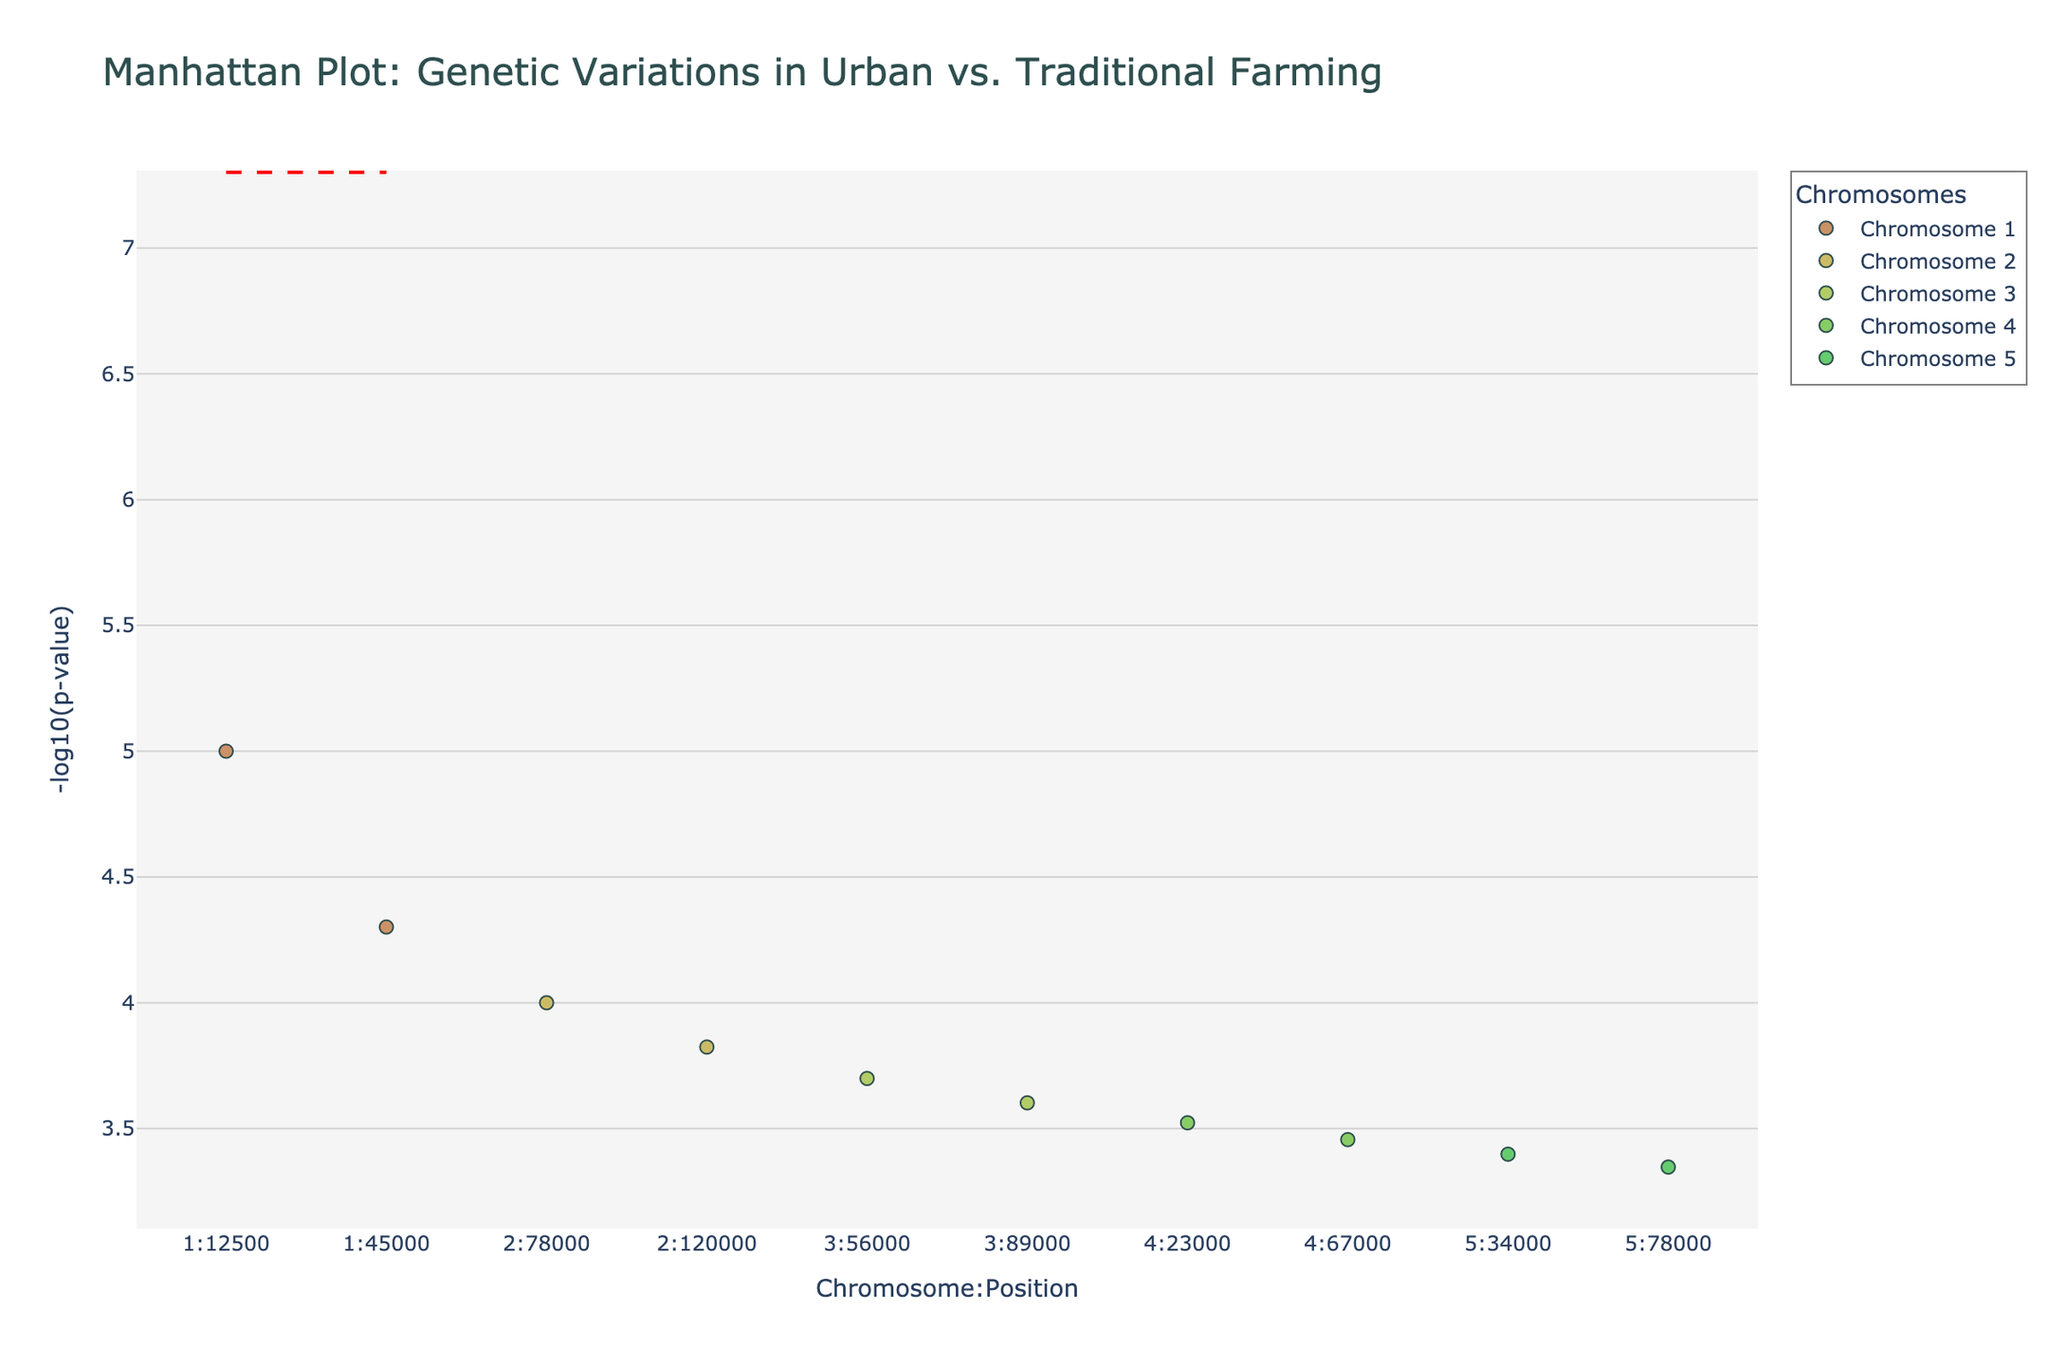What is the title of the plot? The title of the plot is displayed prominently at the top, and it reads "Manhattan Plot: Genetic Variations in Urban vs. Traditional Farming".
Answer: Manhattan Plot: Genetic Variations in Urban vs. Traditional Farming Which data point on Chromosome 1 has the lowest p-value? To find the lowest p-value data point on Chromosome 1, locate the points on Chromosome 1 and identify the point with the highest y-value (since -log10(p-value) is used). This point corresponds to the p-value 0.00001.
Answer: rs1234567 at Position 12500 How many chromosomes are represented in the plot? Each unique chromosome is labeled in the plot. In this case, the plot features chromosomes 1 to 5. Therefore, count the number of unique labels.
Answer: 5 Which crop has a data point with a p-value of 0.00015 on Chromosome 2? First, locate Chromosome 2. Identify the point with the p-value 0.00015. The hover text reveals that this point corresponds to the crop Lettuce.
Answer: Lettuce What is the range of -log10(p-value) for all data points on Chromosome 3? To determine the range, identify the minimum and maximum -log10(p-value) for Chromosome 3. The plot shows data points with -log10(p-values) ranging between -log10(0.0002) and -log10(0.00025).
Answer: 3.6 to 3.69897 Compare the p-values of data points for Lettuce on Chromosome 2. Which urban farm has a higher p-value? There are two points corresponding to Lettuce on Chromosome 2. Compare the p-values, 0.0001 (CityGreens) and 0.00015 (UrbanOasis). Since 0.00015 > 0.0001, determine which farm represents the higher p-value.
Answer: UrbanOasis Which crop has the highest -log10(p-value) on Chromosome 4, and what is the corresponding urban farm? Identify the data points on Chromosome 4 and find the one with the maximum y-value (-log10(p-value)). Inspect the hover text for details.
Answer: Cucumber, DowntownDirt Are there any data points that exceed the threshold line at -log10(5e-8)? Examine the entirety of the plot to see if any points surpass the horizontal line drawn at -log10(5e-8). Since no points appear above this line, we conclude the answer.
Answer: No What is the overall trend in -log10(p-values) across Chromosomes 1 to 5? Observe the distribution of -log10(p-values) across all chromosomes. The trend shows that the -log10(p-values) are generally between around 3.30103 and 5, with no significant outliers observed.
Answer: Generally consistent around 3.30103 to 5 